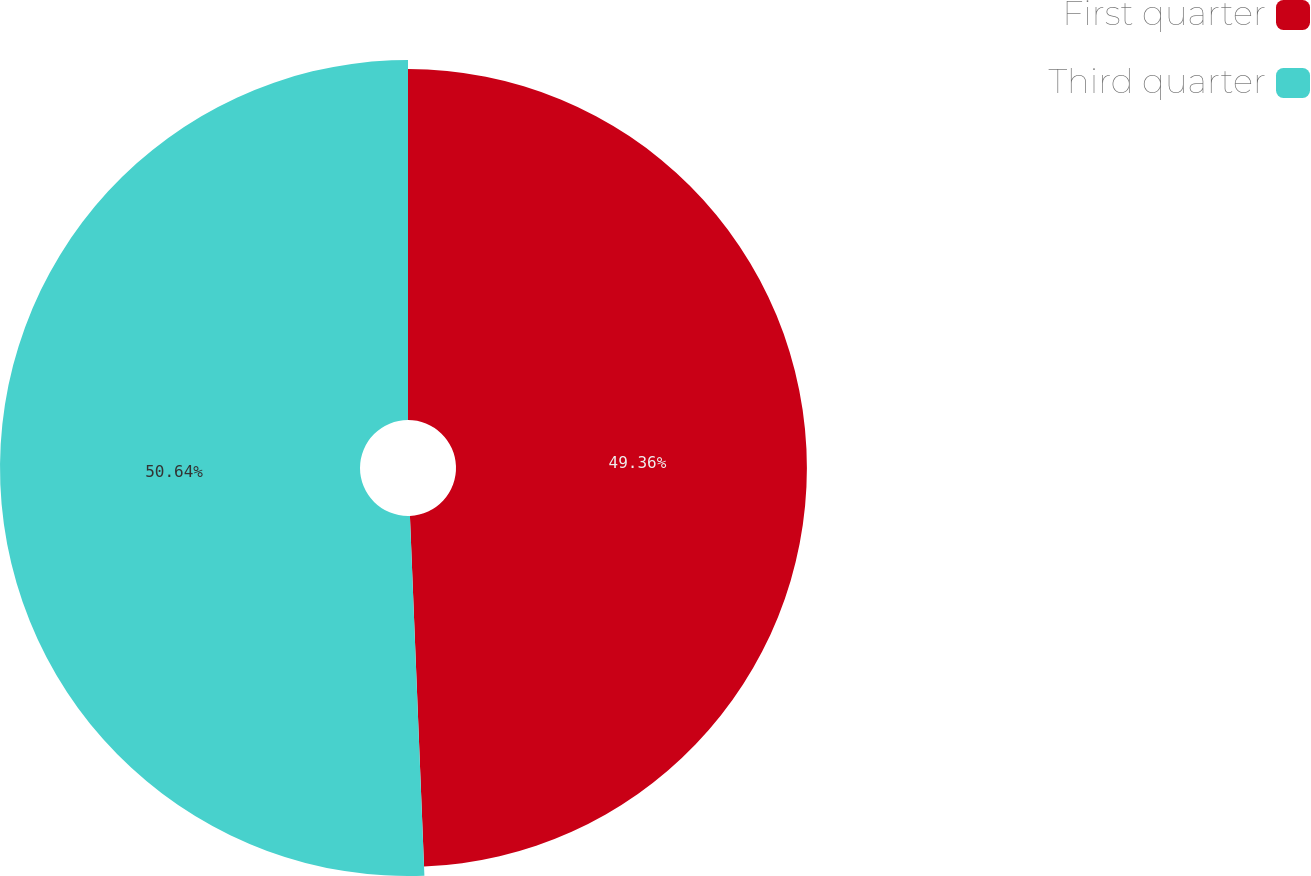Convert chart. <chart><loc_0><loc_0><loc_500><loc_500><pie_chart><fcel>First quarter<fcel>Third quarter<nl><fcel>49.36%<fcel>50.64%<nl></chart> 